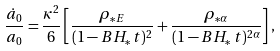<formula> <loc_0><loc_0><loc_500><loc_500>\frac { \dot { a } _ { 0 } } { a _ { 0 } } = \frac { \kappa ^ { 2 } } { 6 } \left [ \frac { \rho _ { * E } } { ( 1 - B H _ { * } \, t ) ^ { 2 } } + \frac { \rho _ { * \alpha } } { ( 1 - B H _ { * } \, t ) ^ { 2 \alpha } } \right ] ,</formula> 